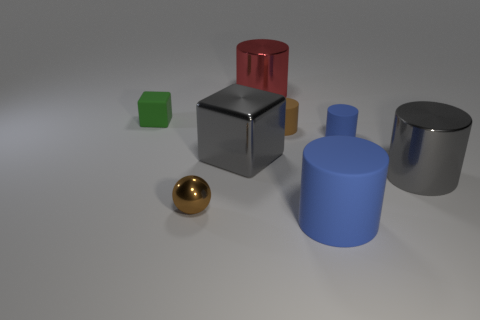Subtract all purple cylinders. Subtract all brown spheres. How many cylinders are left? 5 Subtract all brown cylinders. How many red cubes are left? 0 Add 3 small purples. How many tiny things exist? 0 Subtract all small metal things. Subtract all large metal cubes. How many objects are left? 6 Add 1 tiny blue objects. How many tiny blue objects are left? 2 Add 6 tiny brown objects. How many tiny brown objects exist? 8 Add 1 shiny things. How many objects exist? 9 Subtract all blue cylinders. How many cylinders are left? 3 Subtract all gray metal cylinders. How many cylinders are left? 4 Subtract 0 brown blocks. How many objects are left? 8 